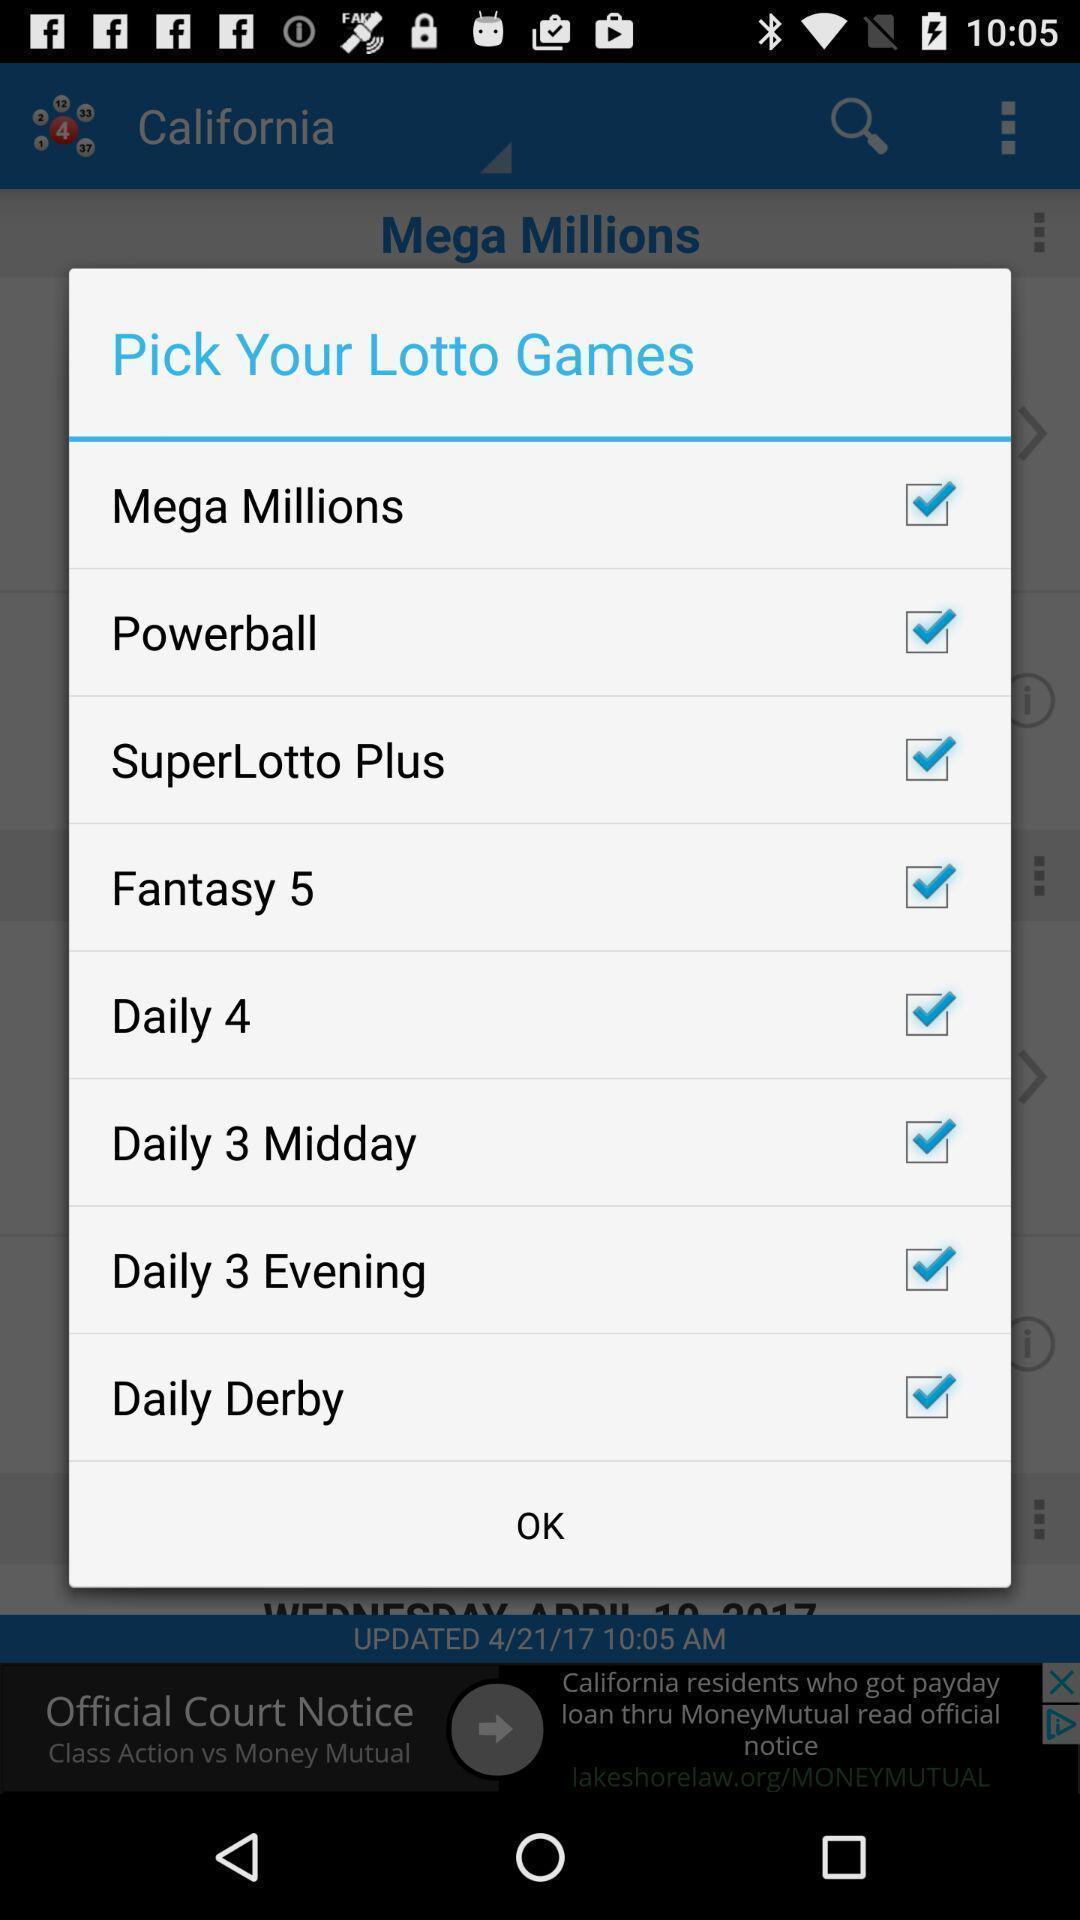Provide a textual representation of this image. Popup showing information about game. 